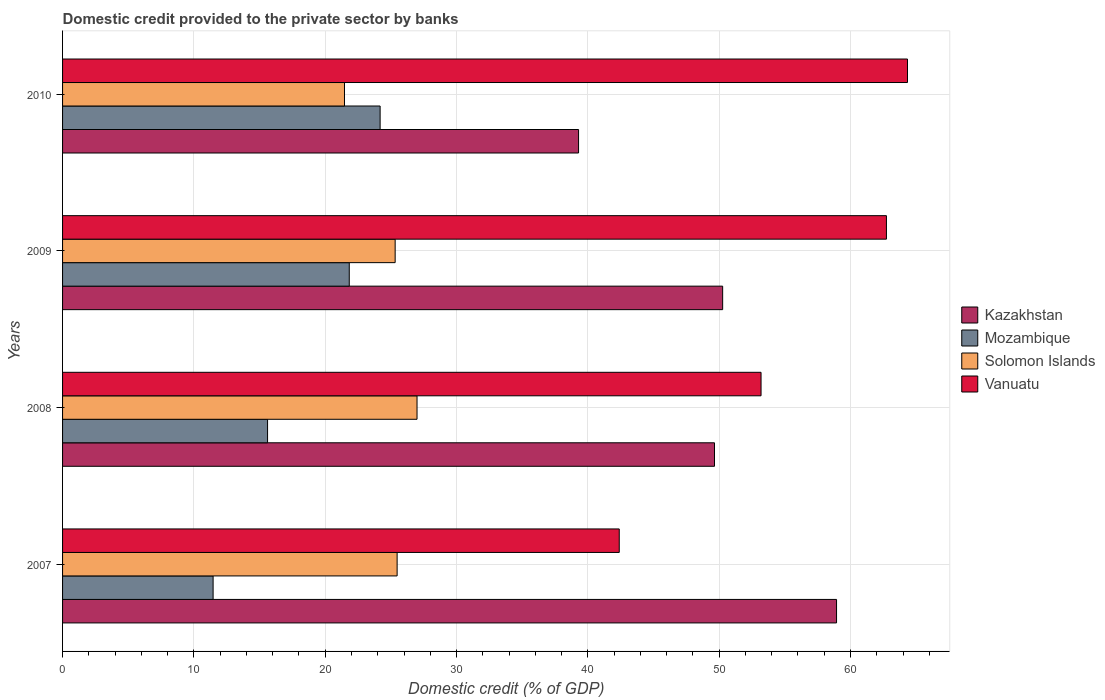How many different coloured bars are there?
Make the answer very short. 4. Are the number of bars per tick equal to the number of legend labels?
Your response must be concise. Yes. How many bars are there on the 2nd tick from the top?
Offer a terse response. 4. How many bars are there on the 4th tick from the bottom?
Give a very brief answer. 4. What is the label of the 3rd group of bars from the top?
Keep it short and to the point. 2008. In how many cases, is the number of bars for a given year not equal to the number of legend labels?
Offer a terse response. 0. What is the domestic credit provided to the private sector by banks in Vanuatu in 2009?
Provide a short and direct response. 62.74. Across all years, what is the maximum domestic credit provided to the private sector by banks in Mozambique?
Keep it short and to the point. 24.18. Across all years, what is the minimum domestic credit provided to the private sector by banks in Kazakhstan?
Your answer should be compact. 39.29. In which year was the domestic credit provided to the private sector by banks in Mozambique maximum?
Provide a short and direct response. 2010. What is the total domestic credit provided to the private sector by banks in Mozambique in the graph?
Your answer should be compact. 73.09. What is the difference between the domestic credit provided to the private sector by banks in Solomon Islands in 2007 and that in 2010?
Your answer should be very brief. 4.01. What is the difference between the domestic credit provided to the private sector by banks in Solomon Islands in 2010 and the domestic credit provided to the private sector by banks in Vanuatu in 2008?
Give a very brief answer. -31.72. What is the average domestic credit provided to the private sector by banks in Solomon Islands per year?
Provide a short and direct response. 24.82. In the year 2007, what is the difference between the domestic credit provided to the private sector by banks in Solomon Islands and domestic credit provided to the private sector by banks in Kazakhstan?
Provide a short and direct response. -33.46. In how many years, is the domestic credit provided to the private sector by banks in Mozambique greater than 60 %?
Keep it short and to the point. 0. What is the ratio of the domestic credit provided to the private sector by banks in Solomon Islands in 2008 to that in 2010?
Offer a terse response. 1.26. Is the domestic credit provided to the private sector by banks in Kazakhstan in 2007 less than that in 2009?
Ensure brevity in your answer.  No. Is the difference between the domestic credit provided to the private sector by banks in Solomon Islands in 2008 and 2010 greater than the difference between the domestic credit provided to the private sector by banks in Kazakhstan in 2008 and 2010?
Your answer should be compact. No. What is the difference between the highest and the second highest domestic credit provided to the private sector by banks in Solomon Islands?
Offer a terse response. 1.52. What is the difference between the highest and the lowest domestic credit provided to the private sector by banks in Mozambique?
Ensure brevity in your answer.  12.72. Is the sum of the domestic credit provided to the private sector by banks in Mozambique in 2008 and 2010 greater than the maximum domestic credit provided to the private sector by banks in Vanuatu across all years?
Ensure brevity in your answer.  No. What does the 2nd bar from the top in 2008 represents?
Your response must be concise. Solomon Islands. What does the 2nd bar from the bottom in 2010 represents?
Ensure brevity in your answer.  Mozambique. Is it the case that in every year, the sum of the domestic credit provided to the private sector by banks in Mozambique and domestic credit provided to the private sector by banks in Solomon Islands is greater than the domestic credit provided to the private sector by banks in Vanuatu?
Provide a short and direct response. No. Are all the bars in the graph horizontal?
Offer a very short reply. Yes. How many years are there in the graph?
Offer a very short reply. 4. How many legend labels are there?
Your answer should be compact. 4. How are the legend labels stacked?
Offer a terse response. Vertical. What is the title of the graph?
Give a very brief answer. Domestic credit provided to the private sector by banks. What is the label or title of the X-axis?
Give a very brief answer. Domestic credit (% of GDP). What is the Domestic credit (% of GDP) of Kazakhstan in 2007?
Offer a very short reply. 58.94. What is the Domestic credit (% of GDP) of Mozambique in 2007?
Offer a terse response. 11.46. What is the Domestic credit (% of GDP) in Solomon Islands in 2007?
Ensure brevity in your answer.  25.48. What is the Domestic credit (% of GDP) of Vanuatu in 2007?
Keep it short and to the point. 42.39. What is the Domestic credit (% of GDP) in Kazakhstan in 2008?
Make the answer very short. 49.64. What is the Domestic credit (% of GDP) in Mozambique in 2008?
Provide a succinct answer. 15.61. What is the Domestic credit (% of GDP) in Solomon Islands in 2008?
Provide a succinct answer. 26.99. What is the Domestic credit (% of GDP) of Vanuatu in 2008?
Ensure brevity in your answer.  53.19. What is the Domestic credit (% of GDP) in Kazakhstan in 2009?
Provide a short and direct response. 50.27. What is the Domestic credit (% of GDP) in Mozambique in 2009?
Give a very brief answer. 21.83. What is the Domestic credit (% of GDP) of Solomon Islands in 2009?
Your response must be concise. 25.33. What is the Domestic credit (% of GDP) in Vanuatu in 2009?
Offer a very short reply. 62.74. What is the Domestic credit (% of GDP) of Kazakhstan in 2010?
Your answer should be compact. 39.29. What is the Domestic credit (% of GDP) of Mozambique in 2010?
Your answer should be compact. 24.18. What is the Domestic credit (% of GDP) of Solomon Islands in 2010?
Provide a succinct answer. 21.47. What is the Domestic credit (% of GDP) in Vanuatu in 2010?
Offer a very short reply. 64.34. Across all years, what is the maximum Domestic credit (% of GDP) of Kazakhstan?
Make the answer very short. 58.94. Across all years, what is the maximum Domestic credit (% of GDP) of Mozambique?
Your response must be concise. 24.18. Across all years, what is the maximum Domestic credit (% of GDP) in Solomon Islands?
Offer a very short reply. 26.99. Across all years, what is the maximum Domestic credit (% of GDP) in Vanuatu?
Your response must be concise. 64.34. Across all years, what is the minimum Domestic credit (% of GDP) of Kazakhstan?
Offer a very short reply. 39.29. Across all years, what is the minimum Domestic credit (% of GDP) of Mozambique?
Give a very brief answer. 11.46. Across all years, what is the minimum Domestic credit (% of GDP) of Solomon Islands?
Your response must be concise. 21.47. Across all years, what is the minimum Domestic credit (% of GDP) of Vanuatu?
Offer a very short reply. 42.39. What is the total Domestic credit (% of GDP) of Kazakhstan in the graph?
Make the answer very short. 198.14. What is the total Domestic credit (% of GDP) in Mozambique in the graph?
Provide a short and direct response. 73.09. What is the total Domestic credit (% of GDP) of Solomon Islands in the graph?
Offer a very short reply. 99.26. What is the total Domestic credit (% of GDP) in Vanuatu in the graph?
Provide a short and direct response. 222.66. What is the difference between the Domestic credit (% of GDP) of Kazakhstan in 2007 and that in 2008?
Offer a very short reply. 9.29. What is the difference between the Domestic credit (% of GDP) of Mozambique in 2007 and that in 2008?
Your answer should be compact. -4.15. What is the difference between the Domestic credit (% of GDP) in Solomon Islands in 2007 and that in 2008?
Your answer should be very brief. -1.52. What is the difference between the Domestic credit (% of GDP) in Vanuatu in 2007 and that in 2008?
Offer a terse response. -10.8. What is the difference between the Domestic credit (% of GDP) of Kazakhstan in 2007 and that in 2009?
Your answer should be compact. 8.67. What is the difference between the Domestic credit (% of GDP) of Mozambique in 2007 and that in 2009?
Provide a short and direct response. -10.37. What is the difference between the Domestic credit (% of GDP) in Solomon Islands in 2007 and that in 2009?
Ensure brevity in your answer.  0.15. What is the difference between the Domestic credit (% of GDP) of Vanuatu in 2007 and that in 2009?
Provide a short and direct response. -20.35. What is the difference between the Domestic credit (% of GDP) in Kazakhstan in 2007 and that in 2010?
Your response must be concise. 19.65. What is the difference between the Domestic credit (% of GDP) in Mozambique in 2007 and that in 2010?
Your answer should be compact. -12.72. What is the difference between the Domestic credit (% of GDP) in Solomon Islands in 2007 and that in 2010?
Make the answer very short. 4.01. What is the difference between the Domestic credit (% of GDP) in Vanuatu in 2007 and that in 2010?
Keep it short and to the point. -21.95. What is the difference between the Domestic credit (% of GDP) of Kazakhstan in 2008 and that in 2009?
Offer a terse response. -0.62. What is the difference between the Domestic credit (% of GDP) in Mozambique in 2008 and that in 2009?
Provide a short and direct response. -6.22. What is the difference between the Domestic credit (% of GDP) of Solomon Islands in 2008 and that in 2009?
Offer a terse response. 1.67. What is the difference between the Domestic credit (% of GDP) of Vanuatu in 2008 and that in 2009?
Offer a very short reply. -9.55. What is the difference between the Domestic credit (% of GDP) of Kazakhstan in 2008 and that in 2010?
Provide a short and direct response. 10.35. What is the difference between the Domestic credit (% of GDP) in Mozambique in 2008 and that in 2010?
Ensure brevity in your answer.  -8.57. What is the difference between the Domestic credit (% of GDP) of Solomon Islands in 2008 and that in 2010?
Offer a terse response. 5.52. What is the difference between the Domestic credit (% of GDP) in Vanuatu in 2008 and that in 2010?
Your answer should be very brief. -11.15. What is the difference between the Domestic credit (% of GDP) in Kazakhstan in 2009 and that in 2010?
Offer a terse response. 10.97. What is the difference between the Domestic credit (% of GDP) in Mozambique in 2009 and that in 2010?
Keep it short and to the point. -2.35. What is the difference between the Domestic credit (% of GDP) in Solomon Islands in 2009 and that in 2010?
Your answer should be compact. 3.86. What is the difference between the Domestic credit (% of GDP) of Vanuatu in 2009 and that in 2010?
Offer a very short reply. -1.6. What is the difference between the Domestic credit (% of GDP) in Kazakhstan in 2007 and the Domestic credit (% of GDP) in Mozambique in 2008?
Keep it short and to the point. 43.33. What is the difference between the Domestic credit (% of GDP) in Kazakhstan in 2007 and the Domestic credit (% of GDP) in Solomon Islands in 2008?
Your answer should be very brief. 31.95. What is the difference between the Domestic credit (% of GDP) of Kazakhstan in 2007 and the Domestic credit (% of GDP) of Vanuatu in 2008?
Your answer should be compact. 5.75. What is the difference between the Domestic credit (% of GDP) in Mozambique in 2007 and the Domestic credit (% of GDP) in Solomon Islands in 2008?
Offer a very short reply. -15.53. What is the difference between the Domestic credit (% of GDP) of Mozambique in 2007 and the Domestic credit (% of GDP) of Vanuatu in 2008?
Your answer should be compact. -41.73. What is the difference between the Domestic credit (% of GDP) of Solomon Islands in 2007 and the Domestic credit (% of GDP) of Vanuatu in 2008?
Your response must be concise. -27.71. What is the difference between the Domestic credit (% of GDP) in Kazakhstan in 2007 and the Domestic credit (% of GDP) in Mozambique in 2009?
Make the answer very short. 37.11. What is the difference between the Domestic credit (% of GDP) in Kazakhstan in 2007 and the Domestic credit (% of GDP) in Solomon Islands in 2009?
Offer a terse response. 33.61. What is the difference between the Domestic credit (% of GDP) of Kazakhstan in 2007 and the Domestic credit (% of GDP) of Vanuatu in 2009?
Keep it short and to the point. -3.8. What is the difference between the Domestic credit (% of GDP) of Mozambique in 2007 and the Domestic credit (% of GDP) of Solomon Islands in 2009?
Ensure brevity in your answer.  -13.86. What is the difference between the Domestic credit (% of GDP) in Mozambique in 2007 and the Domestic credit (% of GDP) in Vanuatu in 2009?
Offer a terse response. -51.27. What is the difference between the Domestic credit (% of GDP) in Solomon Islands in 2007 and the Domestic credit (% of GDP) in Vanuatu in 2009?
Offer a terse response. -37.26. What is the difference between the Domestic credit (% of GDP) in Kazakhstan in 2007 and the Domestic credit (% of GDP) in Mozambique in 2010?
Provide a short and direct response. 34.76. What is the difference between the Domestic credit (% of GDP) of Kazakhstan in 2007 and the Domestic credit (% of GDP) of Solomon Islands in 2010?
Make the answer very short. 37.47. What is the difference between the Domestic credit (% of GDP) in Kazakhstan in 2007 and the Domestic credit (% of GDP) in Vanuatu in 2010?
Offer a very short reply. -5.4. What is the difference between the Domestic credit (% of GDP) of Mozambique in 2007 and the Domestic credit (% of GDP) of Solomon Islands in 2010?
Offer a very short reply. -10. What is the difference between the Domestic credit (% of GDP) in Mozambique in 2007 and the Domestic credit (% of GDP) in Vanuatu in 2010?
Provide a short and direct response. -52.88. What is the difference between the Domestic credit (% of GDP) of Solomon Islands in 2007 and the Domestic credit (% of GDP) of Vanuatu in 2010?
Give a very brief answer. -38.86. What is the difference between the Domestic credit (% of GDP) of Kazakhstan in 2008 and the Domestic credit (% of GDP) of Mozambique in 2009?
Keep it short and to the point. 27.81. What is the difference between the Domestic credit (% of GDP) of Kazakhstan in 2008 and the Domestic credit (% of GDP) of Solomon Islands in 2009?
Your answer should be compact. 24.32. What is the difference between the Domestic credit (% of GDP) of Kazakhstan in 2008 and the Domestic credit (% of GDP) of Vanuatu in 2009?
Your response must be concise. -13.09. What is the difference between the Domestic credit (% of GDP) of Mozambique in 2008 and the Domestic credit (% of GDP) of Solomon Islands in 2009?
Your answer should be compact. -9.72. What is the difference between the Domestic credit (% of GDP) of Mozambique in 2008 and the Domestic credit (% of GDP) of Vanuatu in 2009?
Offer a very short reply. -47.13. What is the difference between the Domestic credit (% of GDP) of Solomon Islands in 2008 and the Domestic credit (% of GDP) of Vanuatu in 2009?
Provide a short and direct response. -35.74. What is the difference between the Domestic credit (% of GDP) of Kazakhstan in 2008 and the Domestic credit (% of GDP) of Mozambique in 2010?
Offer a very short reply. 25.46. What is the difference between the Domestic credit (% of GDP) of Kazakhstan in 2008 and the Domestic credit (% of GDP) of Solomon Islands in 2010?
Your answer should be very brief. 28.18. What is the difference between the Domestic credit (% of GDP) in Kazakhstan in 2008 and the Domestic credit (% of GDP) in Vanuatu in 2010?
Offer a very short reply. -14.7. What is the difference between the Domestic credit (% of GDP) of Mozambique in 2008 and the Domestic credit (% of GDP) of Solomon Islands in 2010?
Keep it short and to the point. -5.86. What is the difference between the Domestic credit (% of GDP) in Mozambique in 2008 and the Domestic credit (% of GDP) in Vanuatu in 2010?
Your answer should be compact. -48.73. What is the difference between the Domestic credit (% of GDP) in Solomon Islands in 2008 and the Domestic credit (% of GDP) in Vanuatu in 2010?
Offer a terse response. -37.35. What is the difference between the Domestic credit (% of GDP) in Kazakhstan in 2009 and the Domestic credit (% of GDP) in Mozambique in 2010?
Your response must be concise. 26.08. What is the difference between the Domestic credit (% of GDP) in Kazakhstan in 2009 and the Domestic credit (% of GDP) in Solomon Islands in 2010?
Provide a succinct answer. 28.8. What is the difference between the Domestic credit (% of GDP) of Kazakhstan in 2009 and the Domestic credit (% of GDP) of Vanuatu in 2010?
Provide a succinct answer. -14.08. What is the difference between the Domestic credit (% of GDP) of Mozambique in 2009 and the Domestic credit (% of GDP) of Solomon Islands in 2010?
Your response must be concise. 0.36. What is the difference between the Domestic credit (% of GDP) in Mozambique in 2009 and the Domestic credit (% of GDP) in Vanuatu in 2010?
Keep it short and to the point. -42.51. What is the difference between the Domestic credit (% of GDP) of Solomon Islands in 2009 and the Domestic credit (% of GDP) of Vanuatu in 2010?
Offer a very short reply. -39.01. What is the average Domestic credit (% of GDP) in Kazakhstan per year?
Offer a very short reply. 49.54. What is the average Domestic credit (% of GDP) of Mozambique per year?
Offer a very short reply. 18.27. What is the average Domestic credit (% of GDP) of Solomon Islands per year?
Provide a short and direct response. 24.82. What is the average Domestic credit (% of GDP) in Vanuatu per year?
Your response must be concise. 55.66. In the year 2007, what is the difference between the Domestic credit (% of GDP) of Kazakhstan and Domestic credit (% of GDP) of Mozambique?
Give a very brief answer. 47.47. In the year 2007, what is the difference between the Domestic credit (% of GDP) in Kazakhstan and Domestic credit (% of GDP) in Solomon Islands?
Provide a succinct answer. 33.46. In the year 2007, what is the difference between the Domestic credit (% of GDP) in Kazakhstan and Domestic credit (% of GDP) in Vanuatu?
Your answer should be very brief. 16.55. In the year 2007, what is the difference between the Domestic credit (% of GDP) of Mozambique and Domestic credit (% of GDP) of Solomon Islands?
Your answer should be compact. -14.01. In the year 2007, what is the difference between the Domestic credit (% of GDP) of Mozambique and Domestic credit (% of GDP) of Vanuatu?
Provide a succinct answer. -30.93. In the year 2007, what is the difference between the Domestic credit (% of GDP) in Solomon Islands and Domestic credit (% of GDP) in Vanuatu?
Make the answer very short. -16.91. In the year 2008, what is the difference between the Domestic credit (% of GDP) in Kazakhstan and Domestic credit (% of GDP) in Mozambique?
Offer a very short reply. 34.03. In the year 2008, what is the difference between the Domestic credit (% of GDP) of Kazakhstan and Domestic credit (% of GDP) of Solomon Islands?
Provide a short and direct response. 22.65. In the year 2008, what is the difference between the Domestic credit (% of GDP) in Kazakhstan and Domestic credit (% of GDP) in Vanuatu?
Offer a very short reply. -3.54. In the year 2008, what is the difference between the Domestic credit (% of GDP) of Mozambique and Domestic credit (% of GDP) of Solomon Islands?
Keep it short and to the point. -11.38. In the year 2008, what is the difference between the Domestic credit (% of GDP) of Mozambique and Domestic credit (% of GDP) of Vanuatu?
Ensure brevity in your answer.  -37.58. In the year 2008, what is the difference between the Domestic credit (% of GDP) of Solomon Islands and Domestic credit (% of GDP) of Vanuatu?
Give a very brief answer. -26.2. In the year 2009, what is the difference between the Domestic credit (% of GDP) in Kazakhstan and Domestic credit (% of GDP) in Mozambique?
Give a very brief answer. 28.43. In the year 2009, what is the difference between the Domestic credit (% of GDP) of Kazakhstan and Domestic credit (% of GDP) of Solomon Islands?
Your answer should be compact. 24.94. In the year 2009, what is the difference between the Domestic credit (% of GDP) in Kazakhstan and Domestic credit (% of GDP) in Vanuatu?
Ensure brevity in your answer.  -12.47. In the year 2009, what is the difference between the Domestic credit (% of GDP) of Mozambique and Domestic credit (% of GDP) of Solomon Islands?
Your response must be concise. -3.49. In the year 2009, what is the difference between the Domestic credit (% of GDP) in Mozambique and Domestic credit (% of GDP) in Vanuatu?
Offer a very short reply. -40.9. In the year 2009, what is the difference between the Domestic credit (% of GDP) of Solomon Islands and Domestic credit (% of GDP) of Vanuatu?
Provide a short and direct response. -37.41. In the year 2010, what is the difference between the Domestic credit (% of GDP) in Kazakhstan and Domestic credit (% of GDP) in Mozambique?
Your answer should be very brief. 15.11. In the year 2010, what is the difference between the Domestic credit (% of GDP) in Kazakhstan and Domestic credit (% of GDP) in Solomon Islands?
Ensure brevity in your answer.  17.82. In the year 2010, what is the difference between the Domestic credit (% of GDP) of Kazakhstan and Domestic credit (% of GDP) of Vanuatu?
Offer a very short reply. -25.05. In the year 2010, what is the difference between the Domestic credit (% of GDP) in Mozambique and Domestic credit (% of GDP) in Solomon Islands?
Offer a terse response. 2.71. In the year 2010, what is the difference between the Domestic credit (% of GDP) in Mozambique and Domestic credit (% of GDP) in Vanuatu?
Keep it short and to the point. -40.16. In the year 2010, what is the difference between the Domestic credit (% of GDP) of Solomon Islands and Domestic credit (% of GDP) of Vanuatu?
Provide a succinct answer. -42.87. What is the ratio of the Domestic credit (% of GDP) in Kazakhstan in 2007 to that in 2008?
Your response must be concise. 1.19. What is the ratio of the Domestic credit (% of GDP) of Mozambique in 2007 to that in 2008?
Your response must be concise. 0.73. What is the ratio of the Domestic credit (% of GDP) in Solomon Islands in 2007 to that in 2008?
Ensure brevity in your answer.  0.94. What is the ratio of the Domestic credit (% of GDP) in Vanuatu in 2007 to that in 2008?
Your answer should be very brief. 0.8. What is the ratio of the Domestic credit (% of GDP) in Kazakhstan in 2007 to that in 2009?
Offer a very short reply. 1.17. What is the ratio of the Domestic credit (% of GDP) of Mozambique in 2007 to that in 2009?
Offer a very short reply. 0.53. What is the ratio of the Domestic credit (% of GDP) of Solomon Islands in 2007 to that in 2009?
Your answer should be compact. 1.01. What is the ratio of the Domestic credit (% of GDP) in Vanuatu in 2007 to that in 2009?
Your answer should be very brief. 0.68. What is the ratio of the Domestic credit (% of GDP) of Kazakhstan in 2007 to that in 2010?
Your response must be concise. 1.5. What is the ratio of the Domestic credit (% of GDP) of Mozambique in 2007 to that in 2010?
Keep it short and to the point. 0.47. What is the ratio of the Domestic credit (% of GDP) in Solomon Islands in 2007 to that in 2010?
Provide a short and direct response. 1.19. What is the ratio of the Domestic credit (% of GDP) in Vanuatu in 2007 to that in 2010?
Keep it short and to the point. 0.66. What is the ratio of the Domestic credit (% of GDP) of Kazakhstan in 2008 to that in 2009?
Keep it short and to the point. 0.99. What is the ratio of the Domestic credit (% of GDP) in Mozambique in 2008 to that in 2009?
Offer a very short reply. 0.71. What is the ratio of the Domestic credit (% of GDP) of Solomon Islands in 2008 to that in 2009?
Provide a short and direct response. 1.07. What is the ratio of the Domestic credit (% of GDP) of Vanuatu in 2008 to that in 2009?
Your answer should be very brief. 0.85. What is the ratio of the Domestic credit (% of GDP) in Kazakhstan in 2008 to that in 2010?
Your answer should be compact. 1.26. What is the ratio of the Domestic credit (% of GDP) in Mozambique in 2008 to that in 2010?
Your answer should be compact. 0.65. What is the ratio of the Domestic credit (% of GDP) of Solomon Islands in 2008 to that in 2010?
Your answer should be very brief. 1.26. What is the ratio of the Domestic credit (% of GDP) of Vanuatu in 2008 to that in 2010?
Your answer should be very brief. 0.83. What is the ratio of the Domestic credit (% of GDP) of Kazakhstan in 2009 to that in 2010?
Your answer should be compact. 1.28. What is the ratio of the Domestic credit (% of GDP) in Mozambique in 2009 to that in 2010?
Your answer should be compact. 0.9. What is the ratio of the Domestic credit (% of GDP) of Solomon Islands in 2009 to that in 2010?
Your answer should be compact. 1.18. What is the ratio of the Domestic credit (% of GDP) in Vanuatu in 2009 to that in 2010?
Your answer should be compact. 0.98. What is the difference between the highest and the second highest Domestic credit (% of GDP) of Kazakhstan?
Your answer should be compact. 8.67. What is the difference between the highest and the second highest Domestic credit (% of GDP) in Mozambique?
Give a very brief answer. 2.35. What is the difference between the highest and the second highest Domestic credit (% of GDP) of Solomon Islands?
Give a very brief answer. 1.52. What is the difference between the highest and the second highest Domestic credit (% of GDP) of Vanuatu?
Your answer should be compact. 1.6. What is the difference between the highest and the lowest Domestic credit (% of GDP) in Kazakhstan?
Ensure brevity in your answer.  19.65. What is the difference between the highest and the lowest Domestic credit (% of GDP) in Mozambique?
Ensure brevity in your answer.  12.72. What is the difference between the highest and the lowest Domestic credit (% of GDP) of Solomon Islands?
Provide a succinct answer. 5.52. What is the difference between the highest and the lowest Domestic credit (% of GDP) in Vanuatu?
Make the answer very short. 21.95. 